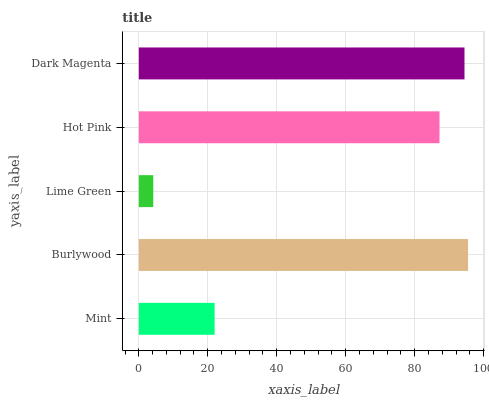Is Lime Green the minimum?
Answer yes or no. Yes. Is Burlywood the maximum?
Answer yes or no. Yes. Is Burlywood the minimum?
Answer yes or no. No. Is Lime Green the maximum?
Answer yes or no. No. Is Burlywood greater than Lime Green?
Answer yes or no. Yes. Is Lime Green less than Burlywood?
Answer yes or no. Yes. Is Lime Green greater than Burlywood?
Answer yes or no. No. Is Burlywood less than Lime Green?
Answer yes or no. No. Is Hot Pink the high median?
Answer yes or no. Yes. Is Hot Pink the low median?
Answer yes or no. Yes. Is Burlywood the high median?
Answer yes or no. No. Is Lime Green the low median?
Answer yes or no. No. 